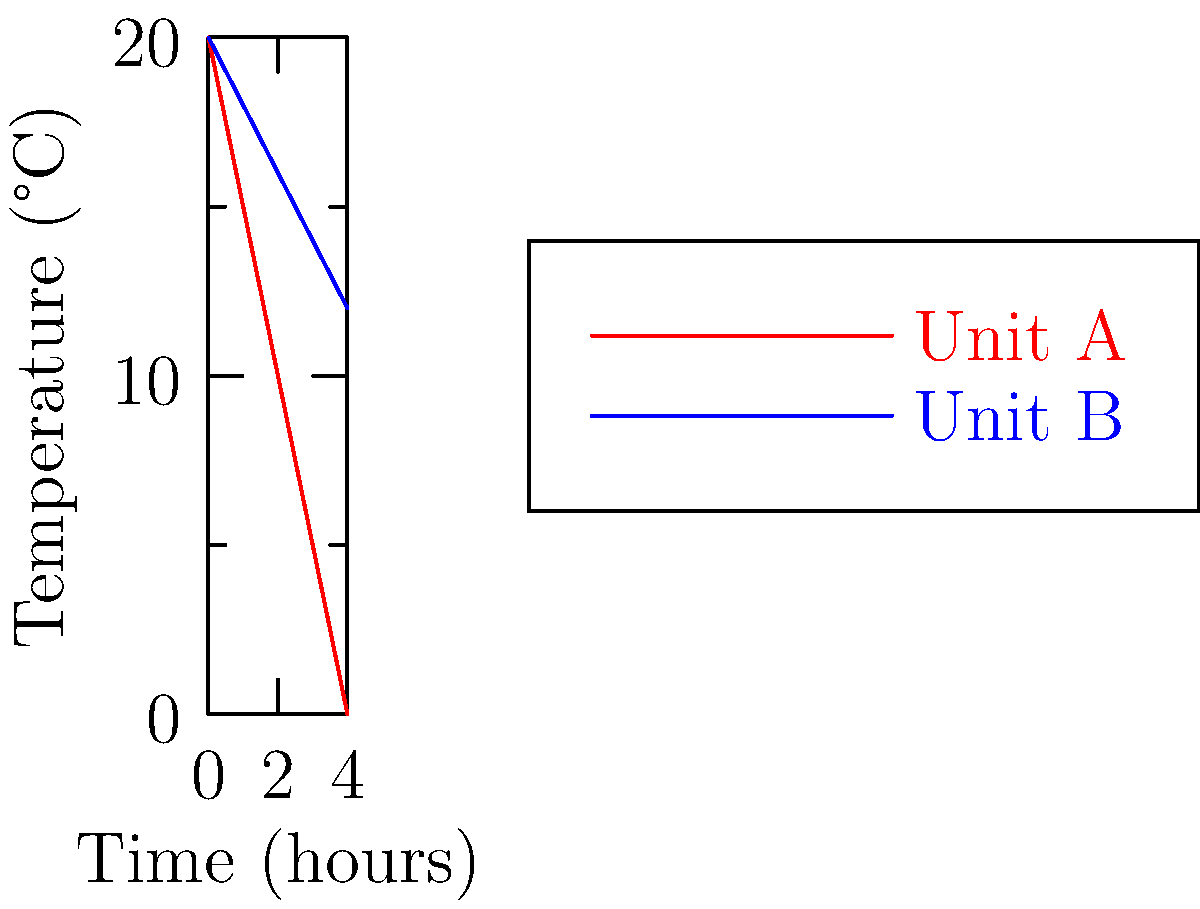As a butcher shop owner, you're comparing two refrigeration units for storing Kosher meats. The graph shows temperature changes over time for Unit A and Unit B. If the initial temperature of the meat is 20°C and the target temperature is 4°C, calculate the difference in cooling rates (in °C/hour) between the two units during the first hour of operation. To solve this problem, we need to follow these steps:

1. Calculate the cooling rate for Unit A:
   - Initial temperature at t = 0: $T_{A0} = 20°C$
   - Temperature after 1 hour: $T_{A1} = 15°C$
   - Cooling rate for Unit A: $R_A = \frac{T_{A0} - T_{A1}}{1\text{ hour}} = \frac{20°C - 15°C}{1\text{ hour}} = 5°C/\text{hour}$

2. Calculate the cooling rate for Unit B:
   - Initial temperature at t = 0: $T_{B0} = 20°C$
   - Temperature after 1 hour: $T_{B1} = 18°C$
   - Cooling rate for Unit B: $R_B = \frac{T_{B0} - T_{B1}}{1\text{ hour}} = \frac{20°C - 18°C}{1\text{ hour}} = 2°C/\text{hour}$

3. Calculate the difference in cooling rates:
   $\text{Difference} = R_A - R_B = 5°C/\text{hour} - 2°C/\text{hour} = 3°C/\text{hour}$

Therefore, the difference in cooling rates between Unit A and Unit B during the first hour of operation is 3°C/hour.
Answer: 3°C/hour 